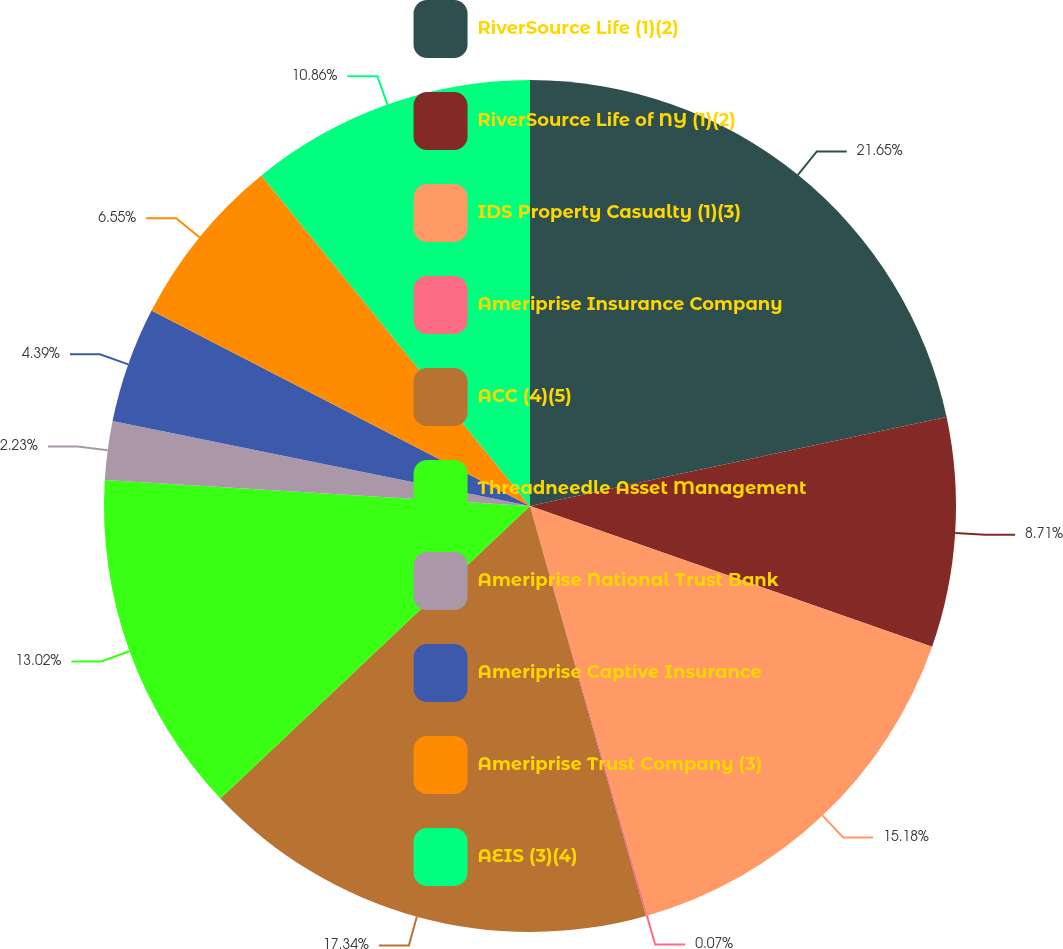Convert chart to OTSL. <chart><loc_0><loc_0><loc_500><loc_500><pie_chart><fcel>RiverSource Life (1)(2)<fcel>RiverSource Life of NY (1)(2)<fcel>IDS Property Casualty (1)(3)<fcel>Ameriprise Insurance Company<fcel>ACC (4)(5)<fcel>Threadneedle Asset Management<fcel>Ameriprise National Trust Bank<fcel>Ameriprise Captive Insurance<fcel>Ameriprise Trust Company (3)<fcel>AEIS (3)(4)<nl><fcel>21.65%<fcel>8.71%<fcel>15.18%<fcel>0.07%<fcel>17.34%<fcel>13.02%<fcel>2.23%<fcel>4.39%<fcel>6.55%<fcel>10.86%<nl></chart> 